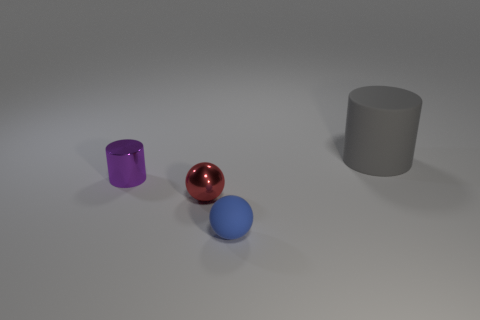Add 3 tiny red shiny things. How many objects exist? 7 Add 3 rubber cylinders. How many rubber cylinders exist? 4 Subtract 0 green balls. How many objects are left? 4 Subtract all large things. Subtract all small balls. How many objects are left? 1 Add 3 small purple objects. How many small purple objects are left? 4 